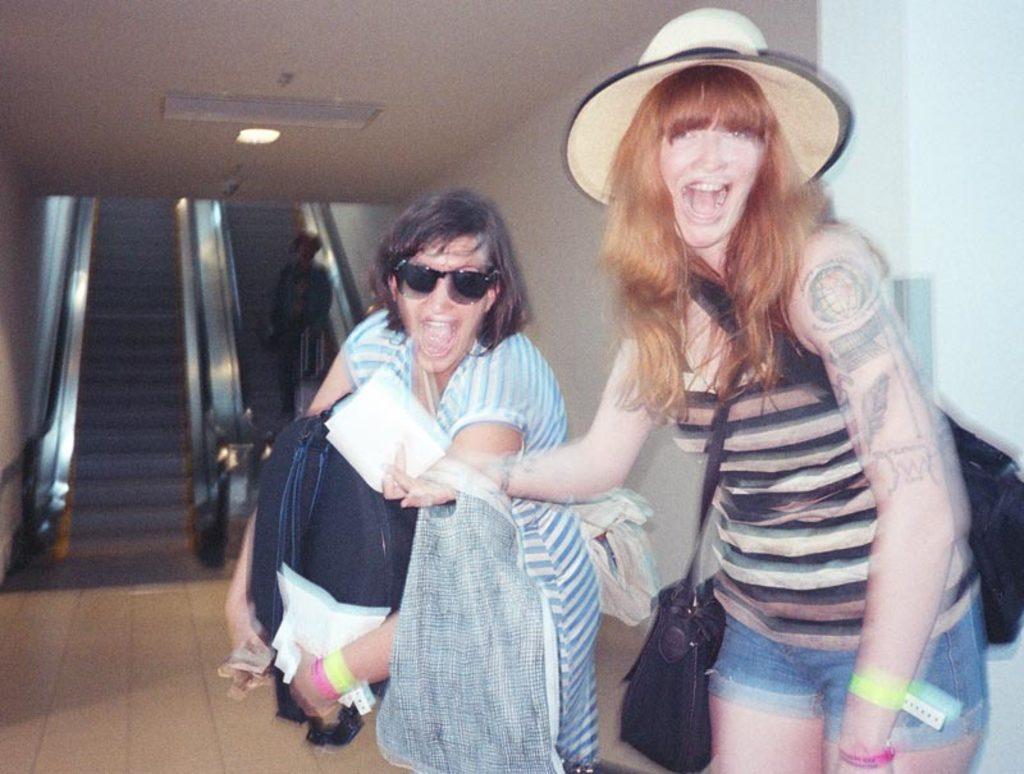Describe this image in one or two sentences. On the right side, there is a woman wearing black color handbags, holding white color papers, a bag, laughing and standing near another woman who is holding a bag, white color papers and other objects and standing on the floor. In the background, there are two elevators. On one of the elevator, there is a person standing and there is a light attached to the roof. 